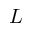Convert formula to latex. <formula><loc_0><loc_0><loc_500><loc_500>L</formula> 